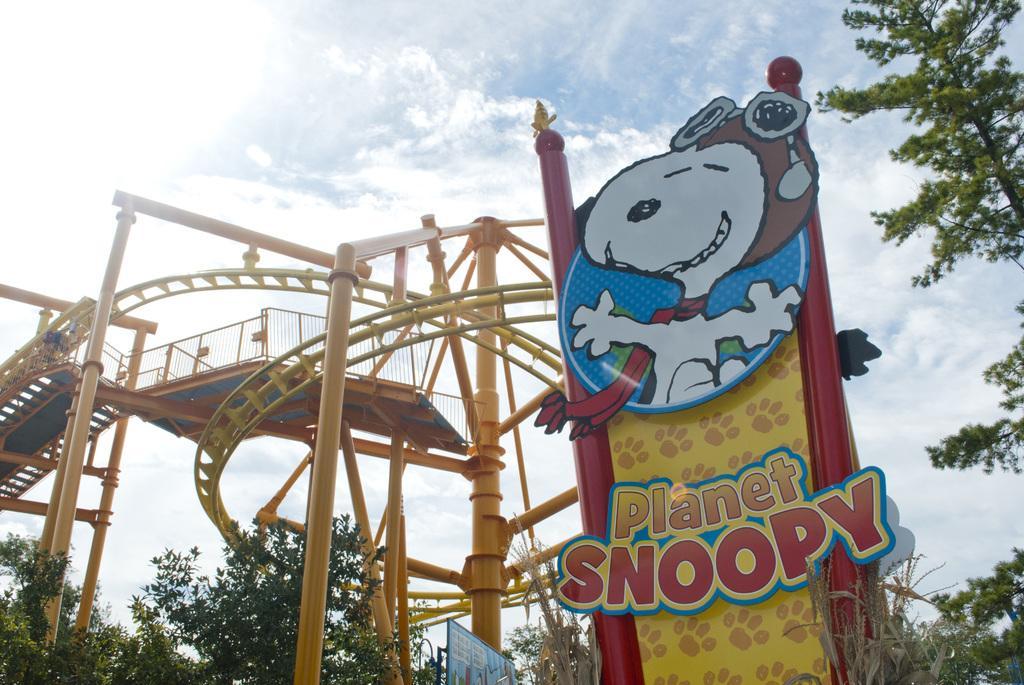How would you summarize this image in a sentence or two? Sky is cloudy. Here we can see trees, hoarding, fence and rods. 